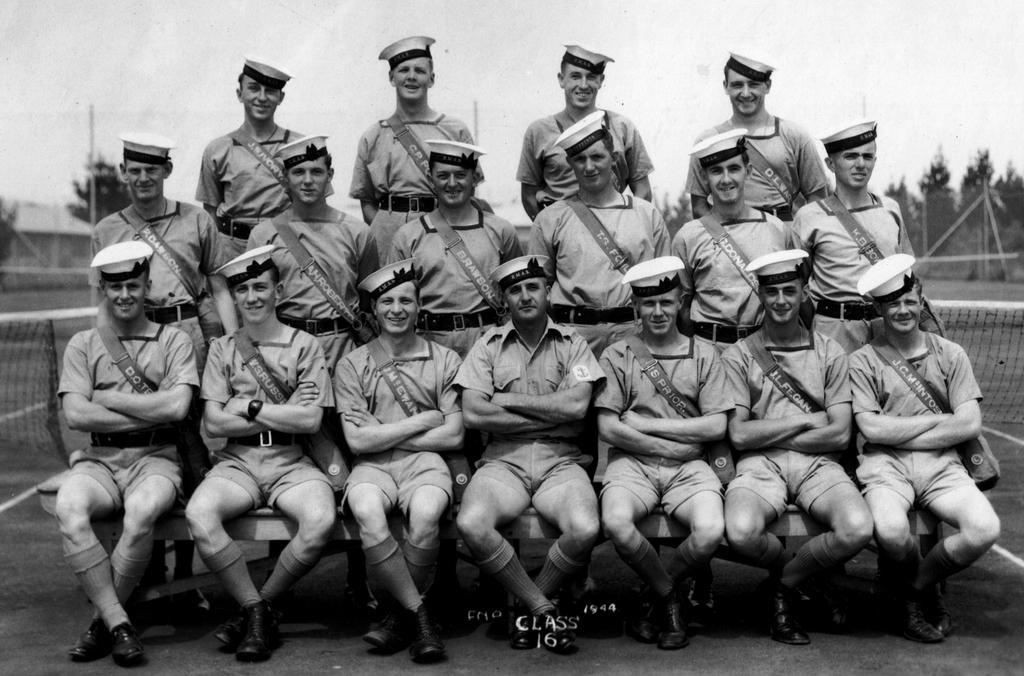Please provide a concise description of this image. There are some people sitting and standing. They are wearing caps. In the back there are trees and net. And it is blurred. At the bottom something is written. 